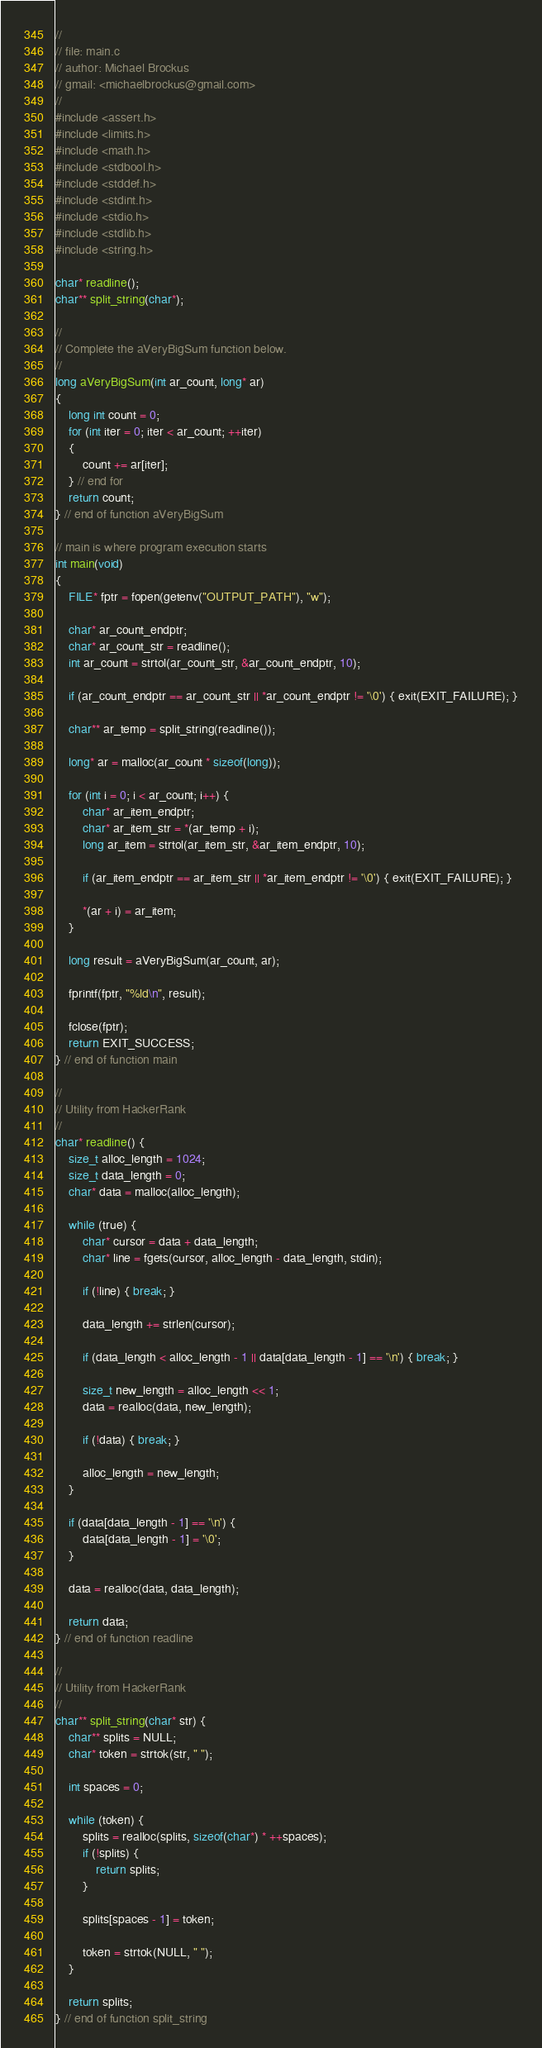<code> <loc_0><loc_0><loc_500><loc_500><_C_>//
// file: main.c
// author: Michael Brockus
// gmail: <michaelbrockus@gmail.com>
//
#include <assert.h>
#include <limits.h>
#include <math.h>
#include <stdbool.h>
#include <stddef.h>
#include <stdint.h>
#include <stdio.h>
#include <stdlib.h>
#include <string.h>

char* readline();
char** split_string(char*);

//
// Complete the aVeryBigSum function below.
//
long aVeryBigSum(int ar_count, long* ar)
{
    long int count = 0;
    for (int iter = 0; iter < ar_count; ++iter)
    {
        count += ar[iter];
    } // end for
    return count; 
} // end of function aVeryBigSum

// main is where program execution starts
int main(void)
{
    FILE* fptr = fopen(getenv("OUTPUT_PATH"), "w");

    char* ar_count_endptr;
    char* ar_count_str = readline();
    int ar_count = strtol(ar_count_str, &ar_count_endptr, 10);

    if (ar_count_endptr == ar_count_str || *ar_count_endptr != '\0') { exit(EXIT_FAILURE); }

    char** ar_temp = split_string(readline());

    long* ar = malloc(ar_count * sizeof(long));

    for (int i = 0; i < ar_count; i++) {
        char* ar_item_endptr;
        char* ar_item_str = *(ar_temp + i);
        long ar_item = strtol(ar_item_str, &ar_item_endptr, 10);

        if (ar_item_endptr == ar_item_str || *ar_item_endptr != '\0') { exit(EXIT_FAILURE); }

        *(ar + i) = ar_item;
    }

    long result = aVeryBigSum(ar_count, ar);

    fprintf(fptr, "%ld\n", result);

    fclose(fptr);
    return EXIT_SUCCESS;
} // end of function main

//
// Utility from HackerRank
//
char* readline() {
    size_t alloc_length = 1024;
    size_t data_length = 0;
    char* data = malloc(alloc_length);

    while (true) {
        char* cursor = data + data_length;
        char* line = fgets(cursor, alloc_length - data_length, stdin);

        if (!line) { break; }

        data_length += strlen(cursor);

        if (data_length < alloc_length - 1 || data[data_length - 1] == '\n') { break; }

        size_t new_length = alloc_length << 1;
        data = realloc(data, new_length);

        if (!data) { break; }

        alloc_length = new_length;
    }

    if (data[data_length - 1] == '\n') {
        data[data_length - 1] = '\0';
    }

    data = realloc(data, data_length);

    return data;
} // end of function readline

//
// Utility from HackerRank
//
char** split_string(char* str) {
    char** splits = NULL;
    char* token = strtok(str, " ");

    int spaces = 0;

    while (token) {
        splits = realloc(splits, sizeof(char*) * ++spaces);
        if (!splits) {
            return splits;
        }

        splits[spaces - 1] = token;

        token = strtok(NULL, " ");
    }

    return splits;
} // end of function split_string
</code> 